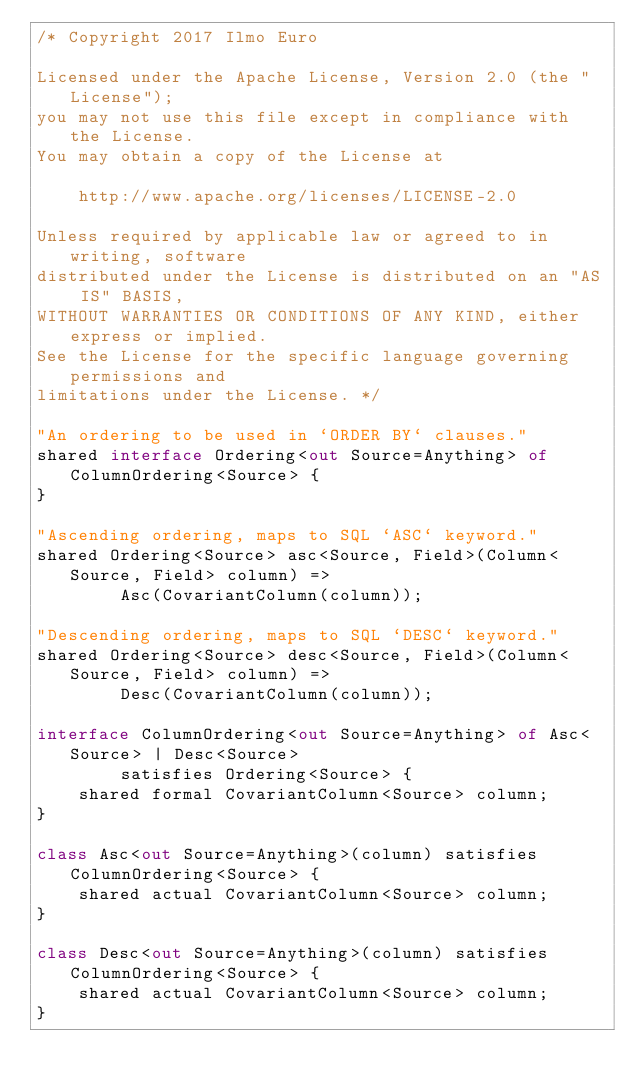<code> <loc_0><loc_0><loc_500><loc_500><_Ceylon_>/* Copyright 2017 Ilmo Euro

Licensed under the Apache License, Version 2.0 (the "License");
you may not use this file except in compliance with the License.
You may obtain a copy of the License at

    http://www.apache.org/licenses/LICENSE-2.0

Unless required by applicable law or agreed to in writing, software
distributed under the License is distributed on an "AS IS" BASIS,
WITHOUT WARRANTIES OR CONDITIONS OF ANY KIND, either express or implied.
See the License for the specific language governing permissions and
limitations under the License. */

"An ordering to be used in `ORDER BY` clauses."
shared interface Ordering<out Source=Anything> of ColumnOrdering<Source> {
}

"Ascending ordering, maps to SQL `ASC` keyword."
shared Ordering<Source> asc<Source, Field>(Column<Source, Field> column) =>
        Asc(CovariantColumn(column));

"Descending ordering, maps to SQL `DESC` keyword."
shared Ordering<Source> desc<Source, Field>(Column<Source, Field> column) =>
        Desc(CovariantColumn(column));

interface ColumnOrdering<out Source=Anything> of Asc<Source> | Desc<Source>
        satisfies Ordering<Source> {
    shared formal CovariantColumn<Source> column;
}

class Asc<out Source=Anything>(column) satisfies ColumnOrdering<Source> {
    shared actual CovariantColumn<Source> column;
}

class Desc<out Source=Anything>(column) satisfies ColumnOrdering<Source> {
    shared actual CovariantColumn<Source> column;
}</code> 